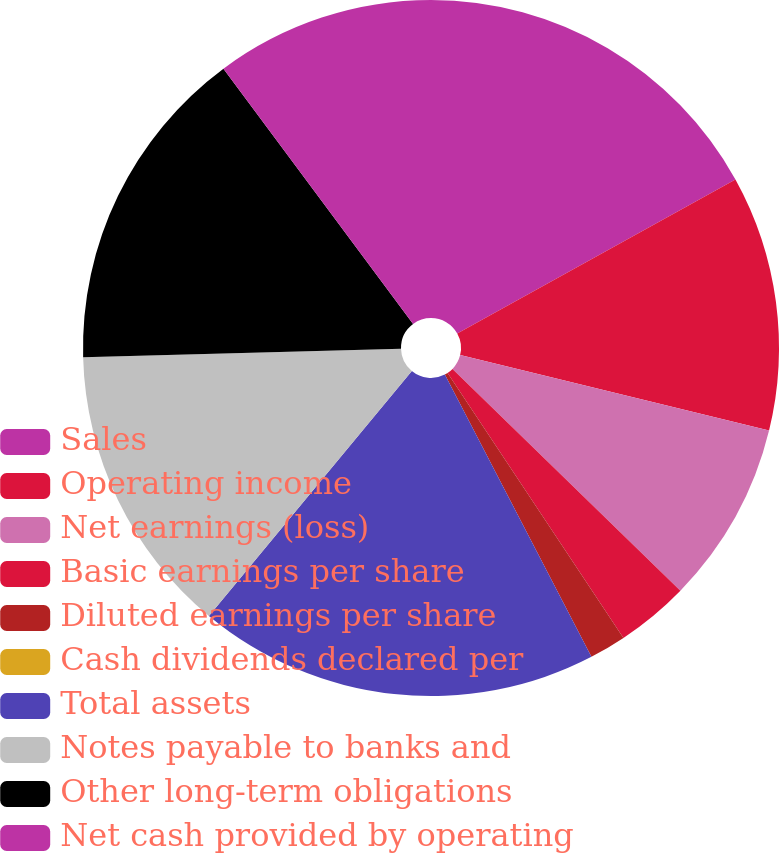Convert chart. <chart><loc_0><loc_0><loc_500><loc_500><pie_chart><fcel>Sales<fcel>Operating income<fcel>Net earnings (loss)<fcel>Basic earnings per share<fcel>Diluted earnings per share<fcel>Cash dividends declared per<fcel>Total assets<fcel>Notes payable to banks and<fcel>Other long-term obligations<fcel>Net cash provided by operating<nl><fcel>16.95%<fcel>11.86%<fcel>8.47%<fcel>3.39%<fcel>1.7%<fcel>0.0%<fcel>18.64%<fcel>13.56%<fcel>15.25%<fcel>10.17%<nl></chart> 